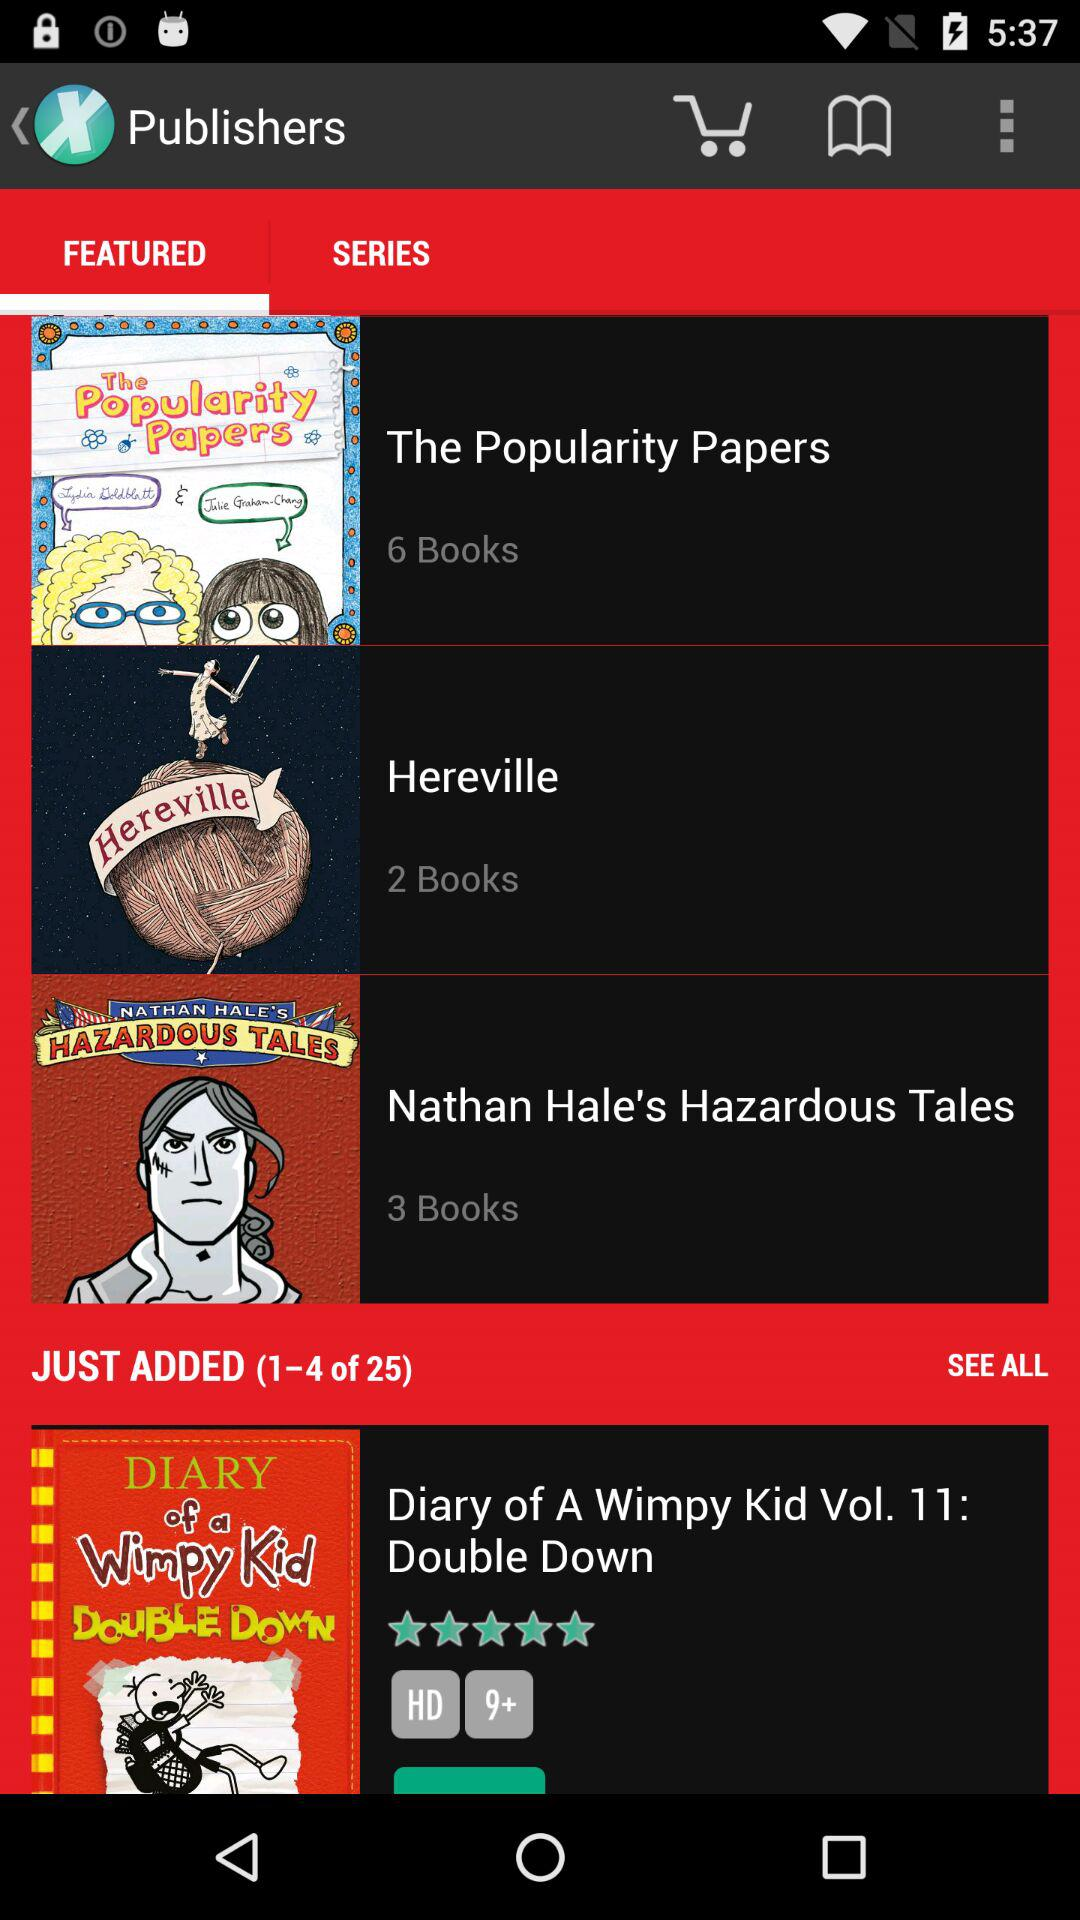How many books are in the series 'Hereville'?
Answer the question using a single word or phrase. 2 